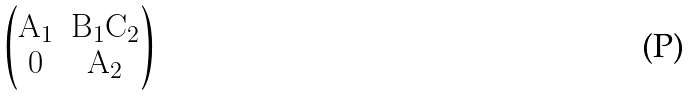Convert formula to latex. <formula><loc_0><loc_0><loc_500><loc_500>\begin{pmatrix} \mathbf A _ { 1 } & \mathbf B _ { 1 } \mathbf C _ { 2 } \\ 0 & \mathbf A _ { 2 } \end{pmatrix}</formula> 